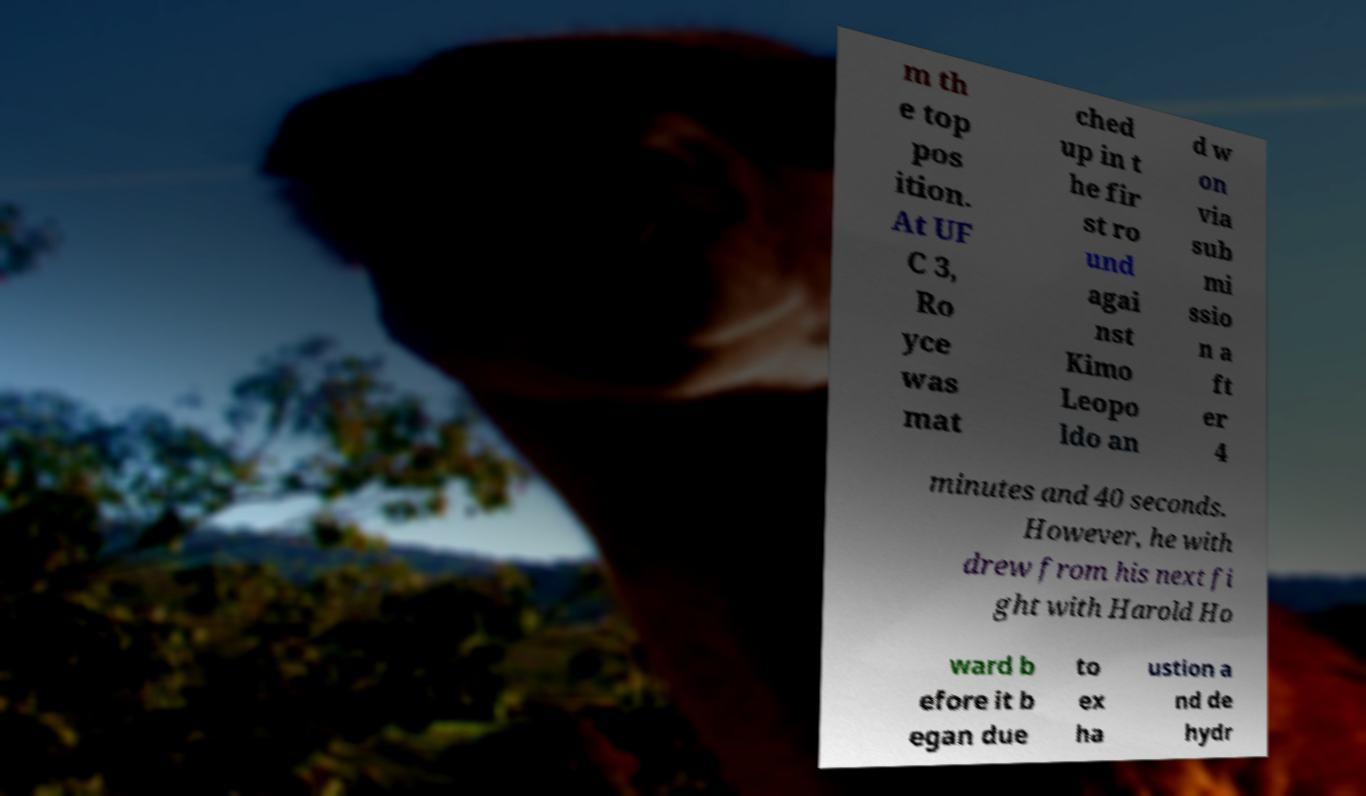Please read and relay the text visible in this image. What does it say? m th e top pos ition. At UF C 3, Ro yce was mat ched up in t he fir st ro und agai nst Kimo Leopo ldo an d w on via sub mi ssio n a ft er 4 minutes and 40 seconds. However, he with drew from his next fi ght with Harold Ho ward b efore it b egan due to ex ha ustion a nd de hydr 